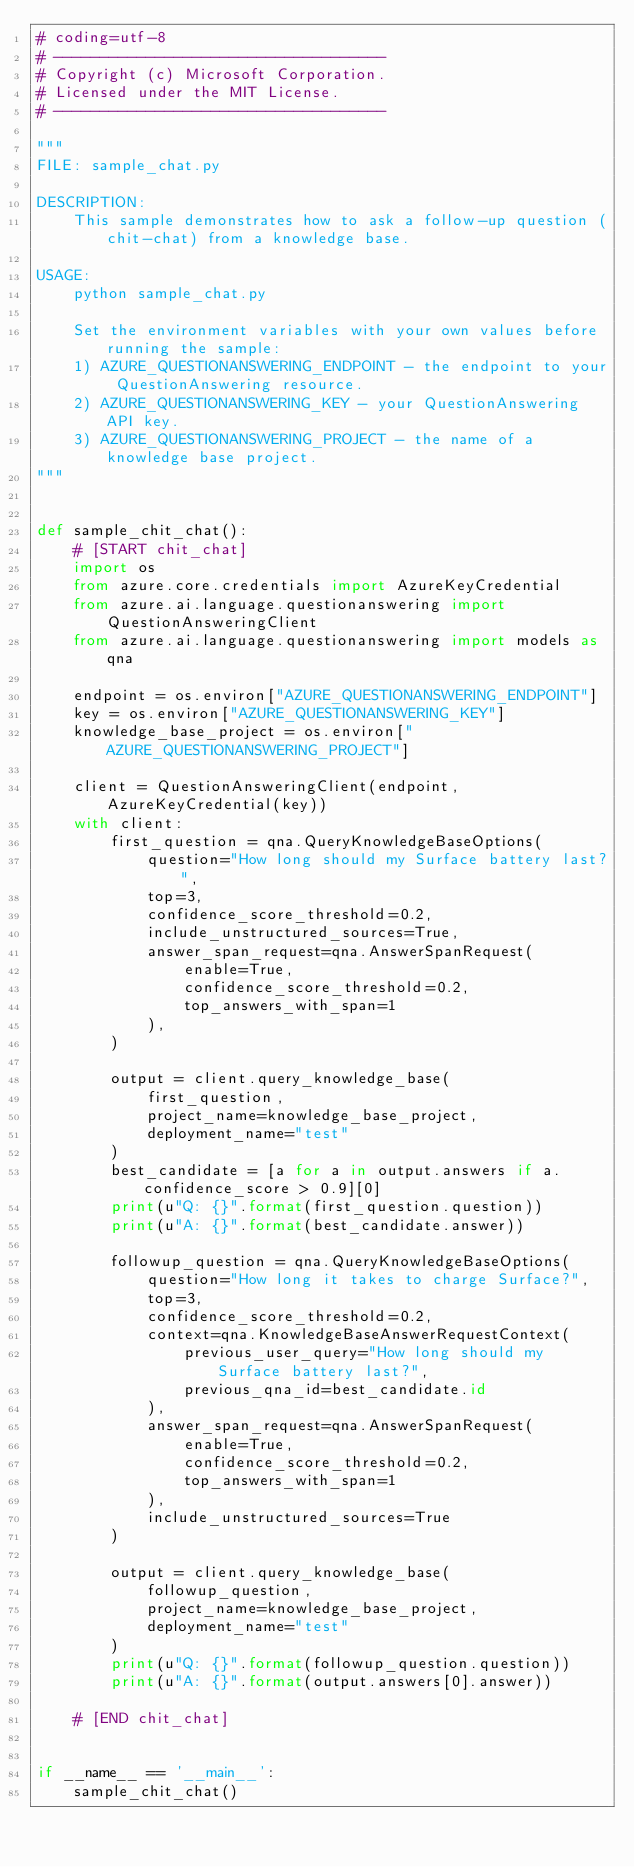Convert code to text. <code><loc_0><loc_0><loc_500><loc_500><_Python_># coding=utf-8
# ------------------------------------
# Copyright (c) Microsoft Corporation.
# Licensed under the MIT License.
# ------------------------------------

"""
FILE: sample_chat.py

DESCRIPTION:
    This sample demonstrates how to ask a follow-up question (chit-chat) from a knowledge base.

USAGE:
    python sample_chat.py

    Set the environment variables with your own values before running the sample:
    1) AZURE_QUESTIONANSWERING_ENDPOINT - the endpoint to your QuestionAnswering resource.
    2) AZURE_QUESTIONANSWERING_KEY - your QuestionAnswering API key.
    3) AZURE_QUESTIONANSWERING_PROJECT - the name of a knowledge base project.
"""


def sample_chit_chat():
    # [START chit_chat]
    import os
    from azure.core.credentials import AzureKeyCredential
    from azure.ai.language.questionanswering import QuestionAnsweringClient
    from azure.ai.language.questionanswering import models as qna

    endpoint = os.environ["AZURE_QUESTIONANSWERING_ENDPOINT"]
    key = os.environ["AZURE_QUESTIONANSWERING_KEY"]
    knowledge_base_project = os.environ["AZURE_QUESTIONANSWERING_PROJECT"]

    client = QuestionAnsweringClient(endpoint, AzureKeyCredential(key))
    with client:
        first_question = qna.QueryKnowledgeBaseOptions(
            question="How long should my Surface battery last?",
            top=3,
            confidence_score_threshold=0.2,
            include_unstructured_sources=True,
            answer_span_request=qna.AnswerSpanRequest(
                enable=True,
                confidence_score_threshold=0.2,
                top_answers_with_span=1
            ),
        )

        output = client.query_knowledge_base(
            first_question,
            project_name=knowledge_base_project,
            deployment_name="test"
        )
        best_candidate = [a for a in output.answers if a.confidence_score > 0.9][0]
        print(u"Q: {}".format(first_question.question))
        print(u"A: {}".format(best_candidate.answer))

        followup_question = qna.QueryKnowledgeBaseOptions(
            question="How long it takes to charge Surface?",
            top=3,
            confidence_score_threshold=0.2,
            context=qna.KnowledgeBaseAnswerRequestContext(
                previous_user_query="How long should my Surface battery last?",
                previous_qna_id=best_candidate.id
            ),
            answer_span_request=qna.AnswerSpanRequest(
                enable=True,
                confidence_score_threshold=0.2,
                top_answers_with_span=1
            ),
            include_unstructured_sources=True
        )

        output = client.query_knowledge_base(
            followup_question,
            project_name=knowledge_base_project,
            deployment_name="test"
        )
        print(u"Q: {}".format(followup_question.question))
        print(u"A: {}".format(output.answers[0].answer))

    # [END chit_chat]


if __name__ == '__main__':
    sample_chit_chat()</code> 